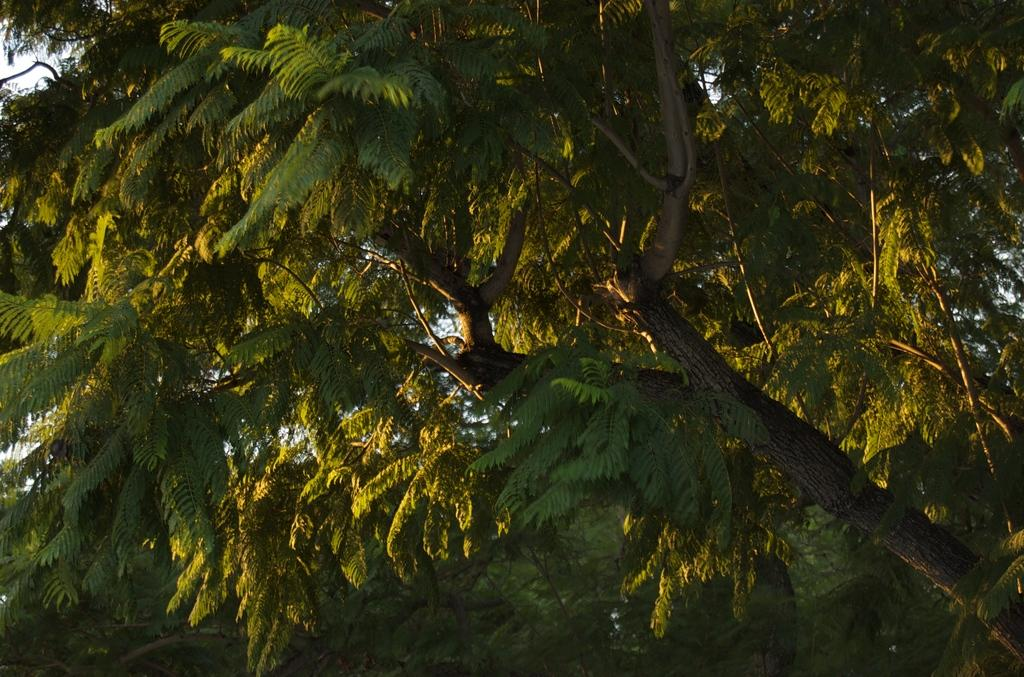What type of vegetation can be seen in the image? There are trees in the image. What color are the trees in the image? The trees are green in color. Can you see a bird biting a duck in the image? There is no bird or duck present in the image. 